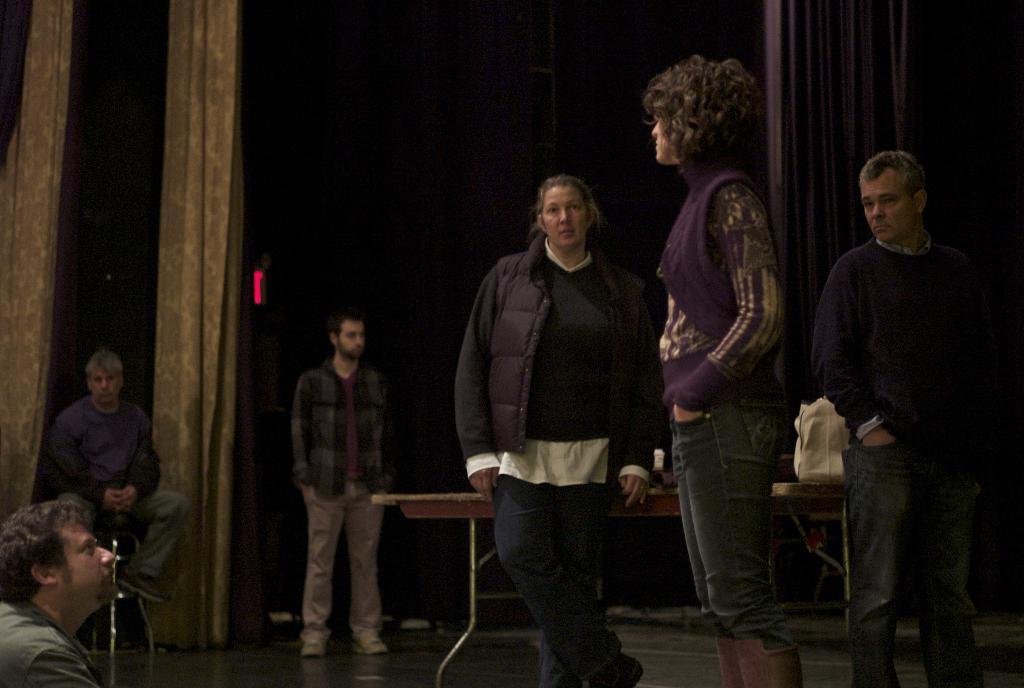How many people are in the image? There are people in the image, but the exact number is not specified. What are some of the people doing in the image? Some people are standing in the image. What object can be seen on a table in the image? There is a bag on a table in the image. How would you describe the lighting in the image? The background of the image is dark. What can be seen in the background of the image? There are curtains visible in the background. How many cans of soda are being carried by the horses in the image? There are no horses or cans of soda present in the image. 